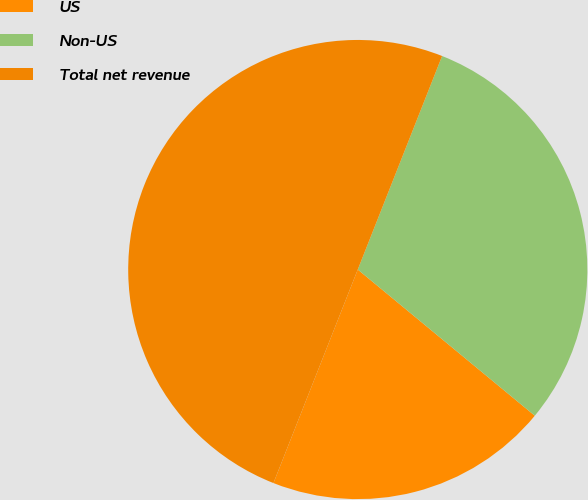Convert chart to OTSL. <chart><loc_0><loc_0><loc_500><loc_500><pie_chart><fcel>US<fcel>Non-US<fcel>Total net revenue<nl><fcel>20.0%<fcel>30.0%<fcel>50.0%<nl></chart> 